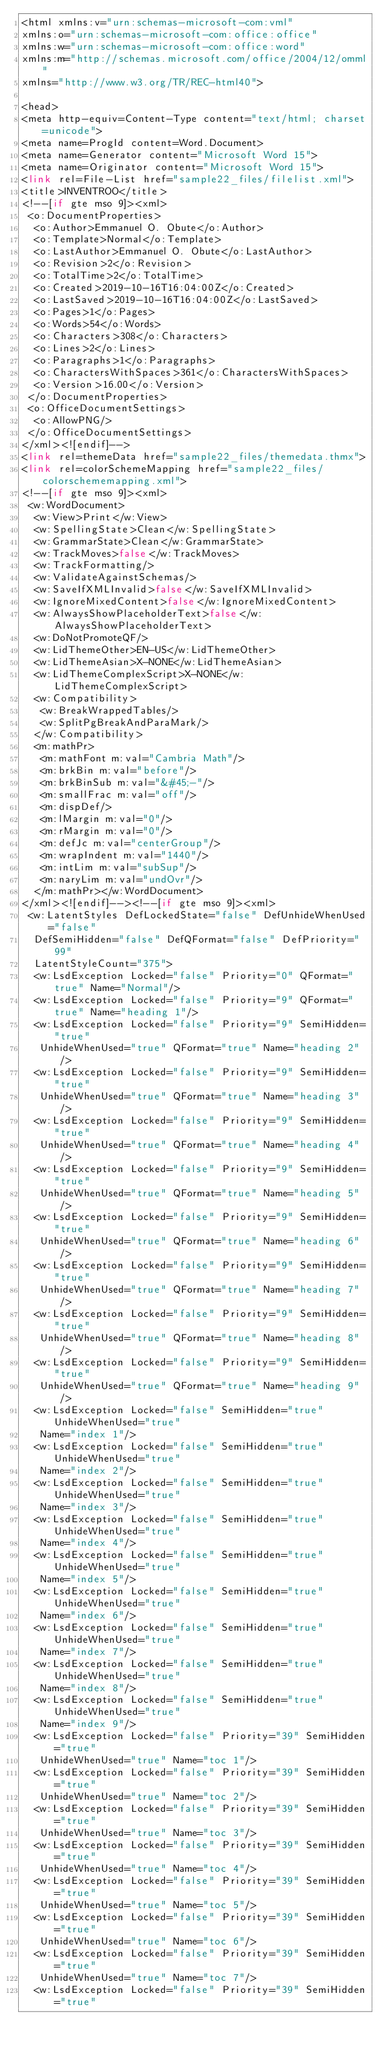Convert code to text. <code><loc_0><loc_0><loc_500><loc_500><_PHP_><html xmlns:v="urn:schemas-microsoft-com:vml"
xmlns:o="urn:schemas-microsoft-com:office:office"
xmlns:w="urn:schemas-microsoft-com:office:word"
xmlns:m="http://schemas.microsoft.com/office/2004/12/omml"
xmlns="http://www.w3.org/TR/REC-html40">

<head>
<meta http-equiv=Content-Type content="text/html; charset=unicode">
<meta name=ProgId content=Word.Document>
<meta name=Generator content="Microsoft Word 15">
<meta name=Originator content="Microsoft Word 15">
<link rel=File-List href="sample22_files/filelist.xml">
<title>INVENTROO</title>
<!--[if gte mso 9]><xml>
 <o:DocumentProperties>
  <o:Author>Emmanuel O. Obute</o:Author>
  <o:Template>Normal</o:Template>
  <o:LastAuthor>Emmanuel O. Obute</o:LastAuthor>
  <o:Revision>2</o:Revision>
  <o:TotalTime>2</o:TotalTime>
  <o:Created>2019-10-16T16:04:00Z</o:Created>
  <o:LastSaved>2019-10-16T16:04:00Z</o:LastSaved>
  <o:Pages>1</o:Pages>
  <o:Words>54</o:Words>
  <o:Characters>308</o:Characters>
  <o:Lines>2</o:Lines>
  <o:Paragraphs>1</o:Paragraphs>
  <o:CharactersWithSpaces>361</o:CharactersWithSpaces>
  <o:Version>16.00</o:Version>
 </o:DocumentProperties>
 <o:OfficeDocumentSettings>
  <o:AllowPNG/>
 </o:OfficeDocumentSettings>
</xml><![endif]-->
<link rel=themeData href="sample22_files/themedata.thmx">
<link rel=colorSchemeMapping href="sample22_files/colorschememapping.xml">
<!--[if gte mso 9]><xml>
 <w:WordDocument>
  <w:View>Print</w:View>
  <w:SpellingState>Clean</w:SpellingState>
  <w:GrammarState>Clean</w:GrammarState>
  <w:TrackMoves>false</w:TrackMoves>
  <w:TrackFormatting/>
  <w:ValidateAgainstSchemas/>
  <w:SaveIfXMLInvalid>false</w:SaveIfXMLInvalid>
  <w:IgnoreMixedContent>false</w:IgnoreMixedContent>
  <w:AlwaysShowPlaceholderText>false</w:AlwaysShowPlaceholderText>
  <w:DoNotPromoteQF/>
  <w:LidThemeOther>EN-US</w:LidThemeOther>
  <w:LidThemeAsian>X-NONE</w:LidThemeAsian>
  <w:LidThemeComplexScript>X-NONE</w:LidThemeComplexScript>
  <w:Compatibility>
   <w:BreakWrappedTables/>
   <w:SplitPgBreakAndParaMark/>
  </w:Compatibility>
  <m:mathPr>
   <m:mathFont m:val="Cambria Math"/>
   <m:brkBin m:val="before"/>
   <m:brkBinSub m:val="&#45;-"/>
   <m:smallFrac m:val="off"/>
   <m:dispDef/>
   <m:lMargin m:val="0"/>
   <m:rMargin m:val="0"/>
   <m:defJc m:val="centerGroup"/>
   <m:wrapIndent m:val="1440"/>
   <m:intLim m:val="subSup"/>
   <m:naryLim m:val="undOvr"/>
  </m:mathPr></w:WordDocument>
</xml><![endif]--><!--[if gte mso 9]><xml>
 <w:LatentStyles DefLockedState="false" DefUnhideWhenUsed="false"
  DefSemiHidden="false" DefQFormat="false" DefPriority="99"
  LatentStyleCount="375">
  <w:LsdException Locked="false" Priority="0" QFormat="true" Name="Normal"/>
  <w:LsdException Locked="false" Priority="9" QFormat="true" Name="heading 1"/>
  <w:LsdException Locked="false" Priority="9" SemiHidden="true"
   UnhideWhenUsed="true" QFormat="true" Name="heading 2"/>
  <w:LsdException Locked="false" Priority="9" SemiHidden="true"
   UnhideWhenUsed="true" QFormat="true" Name="heading 3"/>
  <w:LsdException Locked="false" Priority="9" SemiHidden="true"
   UnhideWhenUsed="true" QFormat="true" Name="heading 4"/>
  <w:LsdException Locked="false" Priority="9" SemiHidden="true"
   UnhideWhenUsed="true" QFormat="true" Name="heading 5"/>
  <w:LsdException Locked="false" Priority="9" SemiHidden="true"
   UnhideWhenUsed="true" QFormat="true" Name="heading 6"/>
  <w:LsdException Locked="false" Priority="9" SemiHidden="true"
   UnhideWhenUsed="true" QFormat="true" Name="heading 7"/>
  <w:LsdException Locked="false" Priority="9" SemiHidden="true"
   UnhideWhenUsed="true" QFormat="true" Name="heading 8"/>
  <w:LsdException Locked="false" Priority="9" SemiHidden="true"
   UnhideWhenUsed="true" QFormat="true" Name="heading 9"/>
  <w:LsdException Locked="false" SemiHidden="true" UnhideWhenUsed="true"
   Name="index 1"/>
  <w:LsdException Locked="false" SemiHidden="true" UnhideWhenUsed="true"
   Name="index 2"/>
  <w:LsdException Locked="false" SemiHidden="true" UnhideWhenUsed="true"
   Name="index 3"/>
  <w:LsdException Locked="false" SemiHidden="true" UnhideWhenUsed="true"
   Name="index 4"/>
  <w:LsdException Locked="false" SemiHidden="true" UnhideWhenUsed="true"
   Name="index 5"/>
  <w:LsdException Locked="false" SemiHidden="true" UnhideWhenUsed="true"
   Name="index 6"/>
  <w:LsdException Locked="false" SemiHidden="true" UnhideWhenUsed="true"
   Name="index 7"/>
  <w:LsdException Locked="false" SemiHidden="true" UnhideWhenUsed="true"
   Name="index 8"/>
  <w:LsdException Locked="false" SemiHidden="true" UnhideWhenUsed="true"
   Name="index 9"/>
  <w:LsdException Locked="false" Priority="39" SemiHidden="true"
   UnhideWhenUsed="true" Name="toc 1"/>
  <w:LsdException Locked="false" Priority="39" SemiHidden="true"
   UnhideWhenUsed="true" Name="toc 2"/>
  <w:LsdException Locked="false" Priority="39" SemiHidden="true"
   UnhideWhenUsed="true" Name="toc 3"/>
  <w:LsdException Locked="false" Priority="39" SemiHidden="true"
   UnhideWhenUsed="true" Name="toc 4"/>
  <w:LsdException Locked="false" Priority="39" SemiHidden="true"
   UnhideWhenUsed="true" Name="toc 5"/>
  <w:LsdException Locked="false" Priority="39" SemiHidden="true"
   UnhideWhenUsed="true" Name="toc 6"/>
  <w:LsdException Locked="false" Priority="39" SemiHidden="true"
   UnhideWhenUsed="true" Name="toc 7"/>
  <w:LsdException Locked="false" Priority="39" SemiHidden="true"</code> 